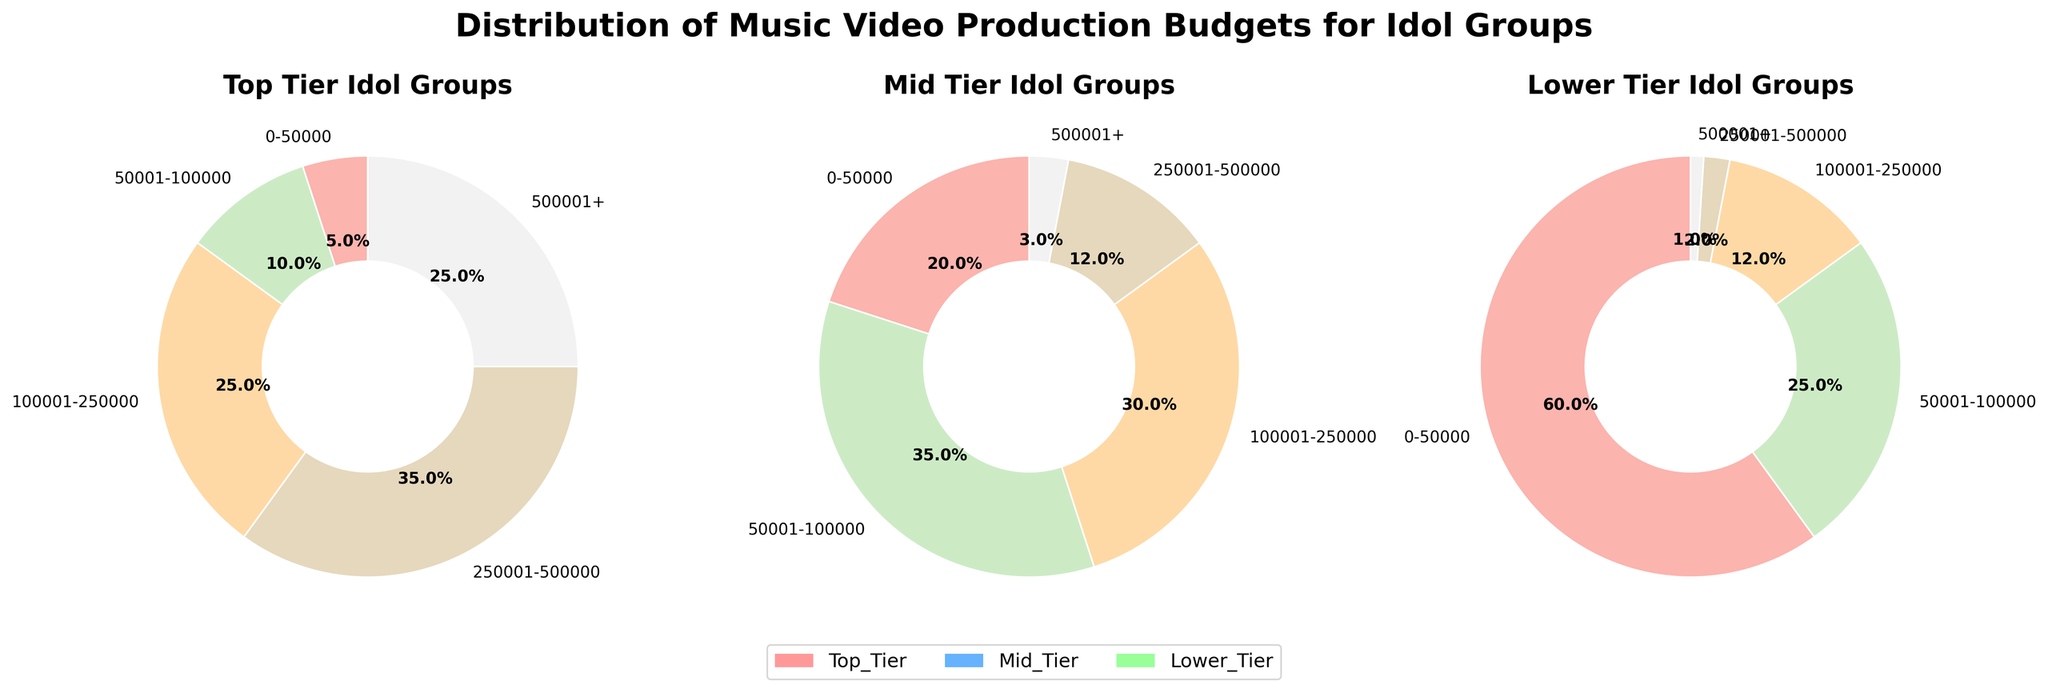What percentage of Top Tier groups have a budget over 100,000? We need to sum the percentages for Top Tier groups in categories over 100,000. These are 100,001-250,000 (25%), 250,001-500,000 (35%), and 500,001+ (25%). So, 25% + 35% + 25% = 85%.
Answer: 85% Which tier has the highest percentage of music videos with a budget within the 0-50,000 range? By comparing the 0-50,000 percentage across tiers: Top Tier (5%), Mid Tier (20%), Lower Tier (60%), the highest percentage is for the Lower Tier at 60%.
Answer: Lower Tier How do the budget distributions of Mid Tier and Lower Tier groups compare in the 500,001+ range? The percentage of music videos with a budget over 500,001 for Mid Tier is 3%, and for Lower Tier is 1%. Thus, Mid Tier has a higher percentage in this range.
Answer: Mid Tier Which tier has the most equal distribution across different budget ranges? We observe the distribution percentages: Top Tier ranges from 5% to 35%, Mid Tier ranges from 3% to 35%, and Lower Tier ranges from 1% to 60%. Mid Tier has the most balanced (less extreme) distribution.
Answer: Mid Tier In the 100,001-250,000 range, how does the Top Tier percentage compare to the Mid Tier percentage? For the 100,001-250,000 range, Top Tier is 25% and Mid Tier is 30%. The Mid Tier has a 5% higher percentage than Top Tier.
Answer: Mid Tier is higher by 5% What is the combined percentage of Mid Tier groups with a budget under 100,000? We sum the percentages of Mid Tier groups in the 0-50,000 (20%) and 50,001-100,000 (35%) ranges, so 20% + 35% = 55%.
Answer: 55% If we focus on the percentage of videos costing above 250,000, which tier has the lowest percentage? We sum the percentages over 250,000: Top Tier (35% + 25% = 60%), Mid Tier (12% + 3% = 15%), and Lower Tier (2% + 1% = 3%). Lower Tier has the lowest at 3%.
Answer: Lower Tier Which budget range has the highest percentage for Top Tier idol groups? For Top Tier, the highest percentage is in the 250,001-500,000 range with 35%.
Answer: 250,001-500,000 